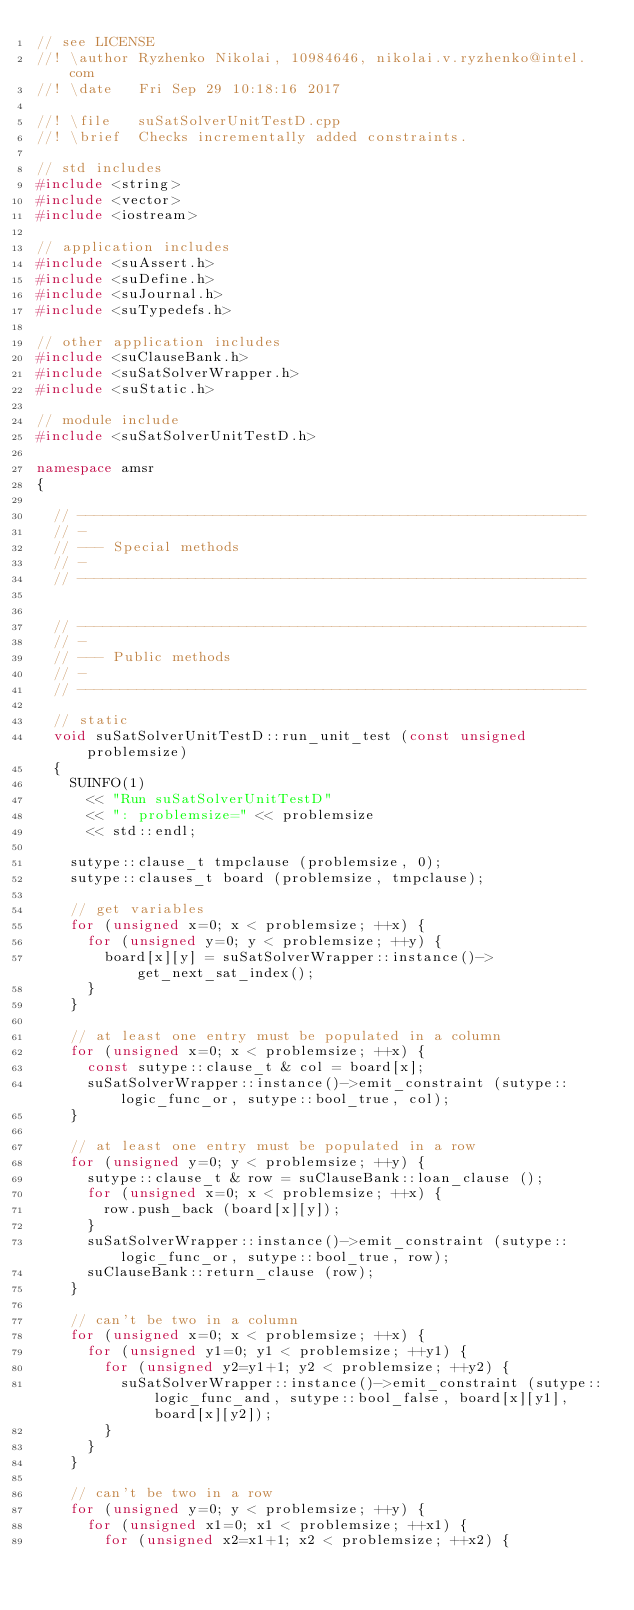<code> <loc_0><loc_0><loc_500><loc_500><_C++_>// see LICENSE
//! \author Ryzhenko Nikolai, 10984646, nikolai.v.ryzhenko@intel.com
//! \date   Fri Sep 29 10:18:16 2017

//! \file   suSatSolverUnitTestD.cpp
//! \brief  Checks incrementally added constraints.

// std includes
#include <string>
#include <vector>
#include <iostream>

// application includes
#include <suAssert.h>
#include <suDefine.h>
#include <suJournal.h>
#include <suTypedefs.h>

// other application includes
#include <suClauseBank.h>
#include <suSatSolverWrapper.h>
#include <suStatic.h>

// module include
#include <suSatSolverUnitTestD.h>

namespace amsr
{

  // ------------------------------------------------------------
  // -
  // --- Special methods
  // -
  // ------------------------------------------------------------


  // ------------------------------------------------------------
  // -
  // --- Public methods
  // -
  // ------------------------------------------------------------

  // static
  void suSatSolverUnitTestD::run_unit_test (const unsigned problemsize)
  {
    SUINFO(1)
      << "Run suSatSolverUnitTestD"
      << ": problemsize=" << problemsize
      << std::endl;
    
    sutype::clause_t tmpclause (problemsize, 0);
    sutype::clauses_t board (problemsize, tmpclause);

    // get variables
    for (unsigned x=0; x < problemsize; ++x) {
      for (unsigned y=0; y < problemsize; ++y) {
        board[x][y] = suSatSolverWrapper::instance()->get_next_sat_index();
      }
    }
    
    // at least one entry must be populated in a column
    for (unsigned x=0; x < problemsize; ++x) {
      const sutype::clause_t & col = board[x];
      suSatSolverWrapper::instance()->emit_constraint (sutype::logic_func_or, sutype::bool_true, col);
    }

    // at least one entry must be populated in a row
    for (unsigned y=0; y < problemsize; ++y) {
      sutype::clause_t & row = suClauseBank::loan_clause ();
      for (unsigned x=0; x < problemsize; ++x) {
        row.push_back (board[x][y]);
      }
      suSatSolverWrapper::instance()->emit_constraint (sutype::logic_func_or, sutype::bool_true, row);
      suClauseBank::return_clause (row);
    }
    
    // can't be two in a column
    for (unsigned x=0; x < problemsize; ++x) {
      for (unsigned y1=0; y1 < problemsize; ++y1) {
        for (unsigned y2=y1+1; y2 < problemsize; ++y2) {
          suSatSolverWrapper::instance()->emit_constraint (sutype::logic_func_and, sutype::bool_false, board[x][y1], board[x][y2]);
        }
      }
    }
    
    // can't be two in a row
    for (unsigned y=0; y < problemsize; ++y) {
      for (unsigned x1=0; x1 < problemsize; ++x1) {
        for (unsigned x2=x1+1; x2 < problemsize; ++x2) {</code> 